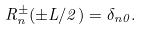<formula> <loc_0><loc_0><loc_500><loc_500>R _ { n } ^ { \pm } ( \pm L / 2 ) = \delta _ { n 0 } .</formula> 